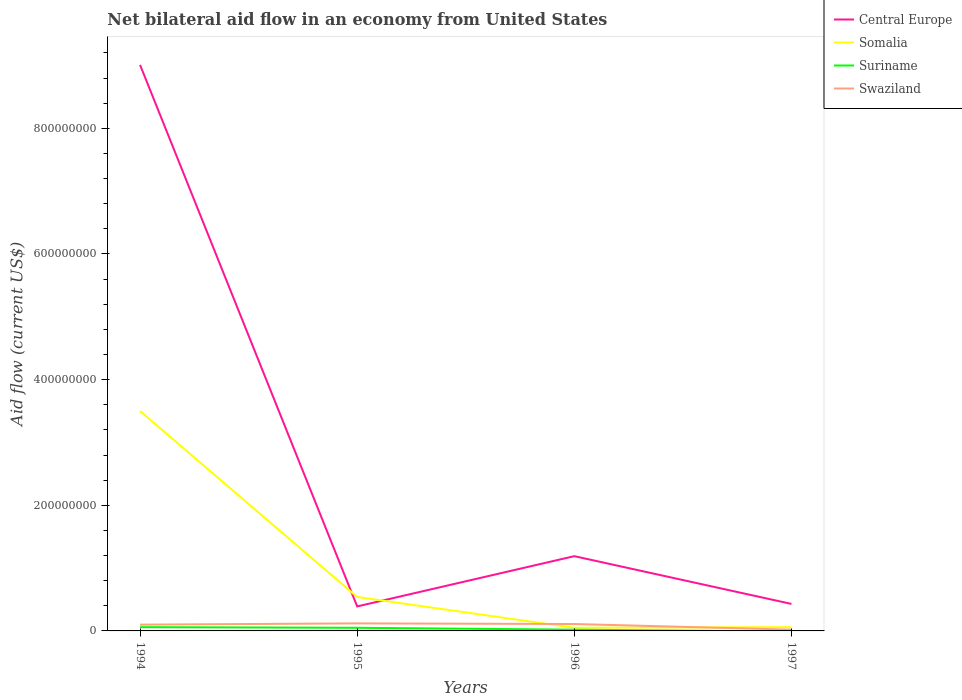How many different coloured lines are there?
Offer a terse response. 4. Across all years, what is the maximum net bilateral aid flow in Central Europe?
Your response must be concise. 3.90e+07. What is the total net bilateral aid flow in Swaziland in the graph?
Your answer should be very brief. 9.00e+06. What is the difference between the highest and the second highest net bilateral aid flow in Somalia?
Offer a very short reply. 3.45e+08. Is the net bilateral aid flow in Suriname strictly greater than the net bilateral aid flow in Central Europe over the years?
Offer a terse response. Yes. How many lines are there?
Provide a short and direct response. 4. Are the values on the major ticks of Y-axis written in scientific E-notation?
Your response must be concise. No. Does the graph contain grids?
Keep it short and to the point. No. How many legend labels are there?
Offer a terse response. 4. How are the legend labels stacked?
Make the answer very short. Vertical. What is the title of the graph?
Your answer should be compact. Net bilateral aid flow in an economy from United States. Does "Japan" appear as one of the legend labels in the graph?
Offer a terse response. No. What is the Aid flow (current US$) in Central Europe in 1994?
Provide a short and direct response. 9.01e+08. What is the Aid flow (current US$) in Somalia in 1994?
Offer a very short reply. 3.50e+08. What is the Aid flow (current US$) of Suriname in 1994?
Provide a short and direct response. 6.00e+06. What is the Aid flow (current US$) of Central Europe in 1995?
Ensure brevity in your answer.  3.90e+07. What is the Aid flow (current US$) of Somalia in 1995?
Provide a short and direct response. 5.40e+07. What is the Aid flow (current US$) of Suriname in 1995?
Offer a terse response. 5.00e+06. What is the Aid flow (current US$) in Swaziland in 1995?
Offer a terse response. 1.20e+07. What is the Aid flow (current US$) in Central Europe in 1996?
Ensure brevity in your answer.  1.19e+08. What is the Aid flow (current US$) in Somalia in 1996?
Provide a succinct answer. 5.00e+06. What is the Aid flow (current US$) in Suriname in 1996?
Ensure brevity in your answer.  2.00e+06. What is the Aid flow (current US$) in Swaziland in 1996?
Provide a short and direct response. 1.10e+07. What is the Aid flow (current US$) in Central Europe in 1997?
Keep it short and to the point. 4.30e+07. What is the Aid flow (current US$) in Somalia in 1997?
Offer a terse response. 6.00e+06. Across all years, what is the maximum Aid flow (current US$) of Central Europe?
Keep it short and to the point. 9.01e+08. Across all years, what is the maximum Aid flow (current US$) in Somalia?
Your response must be concise. 3.50e+08. Across all years, what is the maximum Aid flow (current US$) in Suriname?
Your response must be concise. 6.00e+06. Across all years, what is the maximum Aid flow (current US$) of Swaziland?
Offer a terse response. 1.20e+07. Across all years, what is the minimum Aid flow (current US$) in Central Europe?
Keep it short and to the point. 3.90e+07. Across all years, what is the minimum Aid flow (current US$) in Somalia?
Ensure brevity in your answer.  5.00e+06. Across all years, what is the minimum Aid flow (current US$) in Suriname?
Your response must be concise. 0. Across all years, what is the minimum Aid flow (current US$) in Swaziland?
Ensure brevity in your answer.  2.00e+06. What is the total Aid flow (current US$) of Central Europe in the graph?
Give a very brief answer. 1.10e+09. What is the total Aid flow (current US$) of Somalia in the graph?
Offer a very short reply. 4.15e+08. What is the total Aid flow (current US$) in Suriname in the graph?
Make the answer very short. 1.30e+07. What is the total Aid flow (current US$) of Swaziland in the graph?
Your answer should be compact. 3.50e+07. What is the difference between the Aid flow (current US$) of Central Europe in 1994 and that in 1995?
Keep it short and to the point. 8.62e+08. What is the difference between the Aid flow (current US$) in Somalia in 1994 and that in 1995?
Give a very brief answer. 2.96e+08. What is the difference between the Aid flow (current US$) of Suriname in 1994 and that in 1995?
Your answer should be compact. 1.00e+06. What is the difference between the Aid flow (current US$) of Central Europe in 1994 and that in 1996?
Your answer should be compact. 7.82e+08. What is the difference between the Aid flow (current US$) in Somalia in 1994 and that in 1996?
Your response must be concise. 3.45e+08. What is the difference between the Aid flow (current US$) of Suriname in 1994 and that in 1996?
Make the answer very short. 4.00e+06. What is the difference between the Aid flow (current US$) in Central Europe in 1994 and that in 1997?
Your answer should be compact. 8.58e+08. What is the difference between the Aid flow (current US$) in Somalia in 1994 and that in 1997?
Give a very brief answer. 3.44e+08. What is the difference between the Aid flow (current US$) of Swaziland in 1994 and that in 1997?
Ensure brevity in your answer.  8.00e+06. What is the difference between the Aid flow (current US$) of Central Europe in 1995 and that in 1996?
Make the answer very short. -8.00e+07. What is the difference between the Aid flow (current US$) of Somalia in 1995 and that in 1996?
Provide a short and direct response. 4.90e+07. What is the difference between the Aid flow (current US$) in Swaziland in 1995 and that in 1996?
Your response must be concise. 1.00e+06. What is the difference between the Aid flow (current US$) in Central Europe in 1995 and that in 1997?
Offer a terse response. -4.00e+06. What is the difference between the Aid flow (current US$) of Somalia in 1995 and that in 1997?
Provide a short and direct response. 4.80e+07. What is the difference between the Aid flow (current US$) of Swaziland in 1995 and that in 1997?
Ensure brevity in your answer.  1.00e+07. What is the difference between the Aid flow (current US$) of Central Europe in 1996 and that in 1997?
Offer a very short reply. 7.60e+07. What is the difference between the Aid flow (current US$) in Somalia in 1996 and that in 1997?
Provide a short and direct response. -1.00e+06. What is the difference between the Aid flow (current US$) of Swaziland in 1996 and that in 1997?
Ensure brevity in your answer.  9.00e+06. What is the difference between the Aid flow (current US$) in Central Europe in 1994 and the Aid flow (current US$) in Somalia in 1995?
Give a very brief answer. 8.47e+08. What is the difference between the Aid flow (current US$) in Central Europe in 1994 and the Aid flow (current US$) in Suriname in 1995?
Provide a short and direct response. 8.96e+08. What is the difference between the Aid flow (current US$) of Central Europe in 1994 and the Aid flow (current US$) of Swaziland in 1995?
Make the answer very short. 8.89e+08. What is the difference between the Aid flow (current US$) in Somalia in 1994 and the Aid flow (current US$) in Suriname in 1995?
Offer a terse response. 3.45e+08. What is the difference between the Aid flow (current US$) of Somalia in 1994 and the Aid flow (current US$) of Swaziland in 1995?
Your response must be concise. 3.38e+08. What is the difference between the Aid flow (current US$) in Suriname in 1994 and the Aid flow (current US$) in Swaziland in 1995?
Offer a terse response. -6.00e+06. What is the difference between the Aid flow (current US$) of Central Europe in 1994 and the Aid flow (current US$) of Somalia in 1996?
Your response must be concise. 8.96e+08. What is the difference between the Aid flow (current US$) in Central Europe in 1994 and the Aid flow (current US$) in Suriname in 1996?
Give a very brief answer. 8.99e+08. What is the difference between the Aid flow (current US$) of Central Europe in 1994 and the Aid flow (current US$) of Swaziland in 1996?
Your answer should be compact. 8.90e+08. What is the difference between the Aid flow (current US$) in Somalia in 1994 and the Aid flow (current US$) in Suriname in 1996?
Offer a terse response. 3.48e+08. What is the difference between the Aid flow (current US$) of Somalia in 1994 and the Aid flow (current US$) of Swaziland in 1996?
Give a very brief answer. 3.39e+08. What is the difference between the Aid flow (current US$) of Suriname in 1994 and the Aid flow (current US$) of Swaziland in 1996?
Ensure brevity in your answer.  -5.00e+06. What is the difference between the Aid flow (current US$) in Central Europe in 1994 and the Aid flow (current US$) in Somalia in 1997?
Keep it short and to the point. 8.95e+08. What is the difference between the Aid flow (current US$) in Central Europe in 1994 and the Aid flow (current US$) in Swaziland in 1997?
Offer a very short reply. 8.99e+08. What is the difference between the Aid flow (current US$) of Somalia in 1994 and the Aid flow (current US$) of Swaziland in 1997?
Provide a short and direct response. 3.48e+08. What is the difference between the Aid flow (current US$) in Central Europe in 1995 and the Aid flow (current US$) in Somalia in 1996?
Provide a short and direct response. 3.40e+07. What is the difference between the Aid flow (current US$) in Central Europe in 1995 and the Aid flow (current US$) in Suriname in 1996?
Offer a terse response. 3.70e+07. What is the difference between the Aid flow (current US$) of Central Europe in 1995 and the Aid flow (current US$) of Swaziland in 1996?
Provide a short and direct response. 2.80e+07. What is the difference between the Aid flow (current US$) in Somalia in 1995 and the Aid flow (current US$) in Suriname in 1996?
Provide a short and direct response. 5.20e+07. What is the difference between the Aid flow (current US$) in Somalia in 1995 and the Aid flow (current US$) in Swaziland in 1996?
Offer a terse response. 4.30e+07. What is the difference between the Aid flow (current US$) of Suriname in 1995 and the Aid flow (current US$) of Swaziland in 1996?
Offer a terse response. -6.00e+06. What is the difference between the Aid flow (current US$) of Central Europe in 1995 and the Aid flow (current US$) of Somalia in 1997?
Offer a terse response. 3.30e+07. What is the difference between the Aid flow (current US$) in Central Europe in 1995 and the Aid flow (current US$) in Swaziland in 1997?
Your answer should be compact. 3.70e+07. What is the difference between the Aid flow (current US$) in Somalia in 1995 and the Aid flow (current US$) in Swaziland in 1997?
Provide a short and direct response. 5.20e+07. What is the difference between the Aid flow (current US$) in Central Europe in 1996 and the Aid flow (current US$) in Somalia in 1997?
Provide a succinct answer. 1.13e+08. What is the difference between the Aid flow (current US$) of Central Europe in 1996 and the Aid flow (current US$) of Swaziland in 1997?
Your response must be concise. 1.17e+08. What is the difference between the Aid flow (current US$) in Somalia in 1996 and the Aid flow (current US$) in Swaziland in 1997?
Offer a very short reply. 3.00e+06. What is the average Aid flow (current US$) in Central Europe per year?
Ensure brevity in your answer.  2.76e+08. What is the average Aid flow (current US$) of Somalia per year?
Give a very brief answer. 1.04e+08. What is the average Aid flow (current US$) in Suriname per year?
Give a very brief answer. 3.25e+06. What is the average Aid flow (current US$) in Swaziland per year?
Offer a very short reply. 8.75e+06. In the year 1994, what is the difference between the Aid flow (current US$) in Central Europe and Aid flow (current US$) in Somalia?
Your answer should be very brief. 5.51e+08. In the year 1994, what is the difference between the Aid flow (current US$) of Central Europe and Aid flow (current US$) of Suriname?
Keep it short and to the point. 8.95e+08. In the year 1994, what is the difference between the Aid flow (current US$) of Central Europe and Aid flow (current US$) of Swaziland?
Keep it short and to the point. 8.91e+08. In the year 1994, what is the difference between the Aid flow (current US$) of Somalia and Aid flow (current US$) of Suriname?
Provide a succinct answer. 3.44e+08. In the year 1994, what is the difference between the Aid flow (current US$) in Somalia and Aid flow (current US$) in Swaziland?
Your answer should be very brief. 3.40e+08. In the year 1994, what is the difference between the Aid flow (current US$) in Suriname and Aid flow (current US$) in Swaziland?
Keep it short and to the point. -4.00e+06. In the year 1995, what is the difference between the Aid flow (current US$) of Central Europe and Aid flow (current US$) of Somalia?
Offer a terse response. -1.50e+07. In the year 1995, what is the difference between the Aid flow (current US$) in Central Europe and Aid flow (current US$) in Suriname?
Keep it short and to the point. 3.40e+07. In the year 1995, what is the difference between the Aid flow (current US$) of Central Europe and Aid flow (current US$) of Swaziland?
Ensure brevity in your answer.  2.70e+07. In the year 1995, what is the difference between the Aid flow (current US$) in Somalia and Aid flow (current US$) in Suriname?
Keep it short and to the point. 4.90e+07. In the year 1995, what is the difference between the Aid flow (current US$) in Somalia and Aid flow (current US$) in Swaziland?
Offer a very short reply. 4.20e+07. In the year 1995, what is the difference between the Aid flow (current US$) of Suriname and Aid flow (current US$) of Swaziland?
Your response must be concise. -7.00e+06. In the year 1996, what is the difference between the Aid flow (current US$) of Central Europe and Aid flow (current US$) of Somalia?
Offer a terse response. 1.14e+08. In the year 1996, what is the difference between the Aid flow (current US$) in Central Europe and Aid flow (current US$) in Suriname?
Your answer should be very brief. 1.17e+08. In the year 1996, what is the difference between the Aid flow (current US$) in Central Europe and Aid flow (current US$) in Swaziland?
Your answer should be compact. 1.08e+08. In the year 1996, what is the difference between the Aid flow (current US$) of Somalia and Aid flow (current US$) of Suriname?
Your response must be concise. 3.00e+06. In the year 1996, what is the difference between the Aid flow (current US$) of Somalia and Aid flow (current US$) of Swaziland?
Make the answer very short. -6.00e+06. In the year 1996, what is the difference between the Aid flow (current US$) in Suriname and Aid flow (current US$) in Swaziland?
Provide a short and direct response. -9.00e+06. In the year 1997, what is the difference between the Aid flow (current US$) in Central Europe and Aid flow (current US$) in Somalia?
Your response must be concise. 3.70e+07. In the year 1997, what is the difference between the Aid flow (current US$) in Central Europe and Aid flow (current US$) in Swaziland?
Your answer should be very brief. 4.10e+07. In the year 1997, what is the difference between the Aid flow (current US$) of Somalia and Aid flow (current US$) of Swaziland?
Your answer should be compact. 4.00e+06. What is the ratio of the Aid flow (current US$) of Central Europe in 1994 to that in 1995?
Offer a terse response. 23.1. What is the ratio of the Aid flow (current US$) of Somalia in 1994 to that in 1995?
Your answer should be very brief. 6.48. What is the ratio of the Aid flow (current US$) in Suriname in 1994 to that in 1995?
Your answer should be compact. 1.2. What is the ratio of the Aid flow (current US$) in Swaziland in 1994 to that in 1995?
Offer a terse response. 0.83. What is the ratio of the Aid flow (current US$) in Central Europe in 1994 to that in 1996?
Provide a succinct answer. 7.57. What is the ratio of the Aid flow (current US$) of Central Europe in 1994 to that in 1997?
Your response must be concise. 20.95. What is the ratio of the Aid flow (current US$) of Somalia in 1994 to that in 1997?
Your answer should be very brief. 58.33. What is the ratio of the Aid flow (current US$) of Swaziland in 1994 to that in 1997?
Your response must be concise. 5. What is the ratio of the Aid flow (current US$) of Central Europe in 1995 to that in 1996?
Make the answer very short. 0.33. What is the ratio of the Aid flow (current US$) in Somalia in 1995 to that in 1996?
Provide a short and direct response. 10.8. What is the ratio of the Aid flow (current US$) in Suriname in 1995 to that in 1996?
Offer a very short reply. 2.5. What is the ratio of the Aid flow (current US$) of Swaziland in 1995 to that in 1996?
Keep it short and to the point. 1.09. What is the ratio of the Aid flow (current US$) of Central Europe in 1995 to that in 1997?
Keep it short and to the point. 0.91. What is the ratio of the Aid flow (current US$) in Swaziland in 1995 to that in 1997?
Keep it short and to the point. 6. What is the ratio of the Aid flow (current US$) in Central Europe in 1996 to that in 1997?
Keep it short and to the point. 2.77. What is the ratio of the Aid flow (current US$) in Somalia in 1996 to that in 1997?
Offer a terse response. 0.83. What is the ratio of the Aid flow (current US$) of Swaziland in 1996 to that in 1997?
Ensure brevity in your answer.  5.5. What is the difference between the highest and the second highest Aid flow (current US$) in Central Europe?
Make the answer very short. 7.82e+08. What is the difference between the highest and the second highest Aid flow (current US$) in Somalia?
Make the answer very short. 2.96e+08. What is the difference between the highest and the lowest Aid flow (current US$) of Central Europe?
Your answer should be very brief. 8.62e+08. What is the difference between the highest and the lowest Aid flow (current US$) in Somalia?
Give a very brief answer. 3.45e+08. What is the difference between the highest and the lowest Aid flow (current US$) in Suriname?
Make the answer very short. 6.00e+06. What is the difference between the highest and the lowest Aid flow (current US$) in Swaziland?
Ensure brevity in your answer.  1.00e+07. 